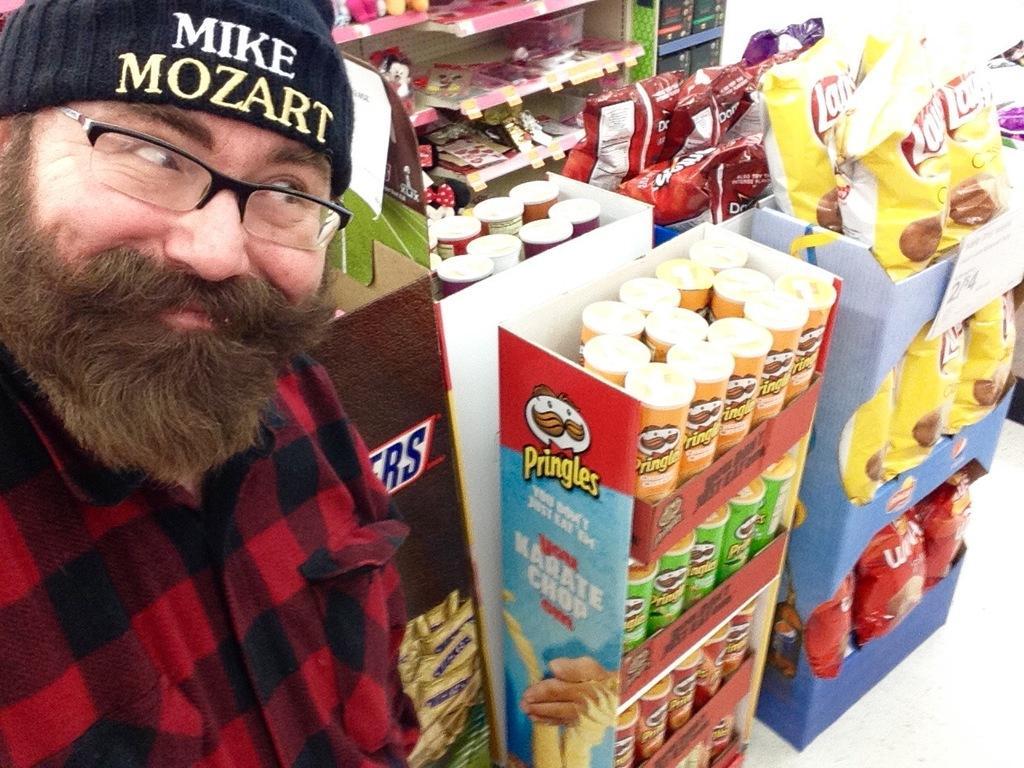Could you give a brief overview of what you see in this image? There is a man wore glasses and cap and smiling. We can see packets and boxes in boxes. Background we can see objects in racks. 